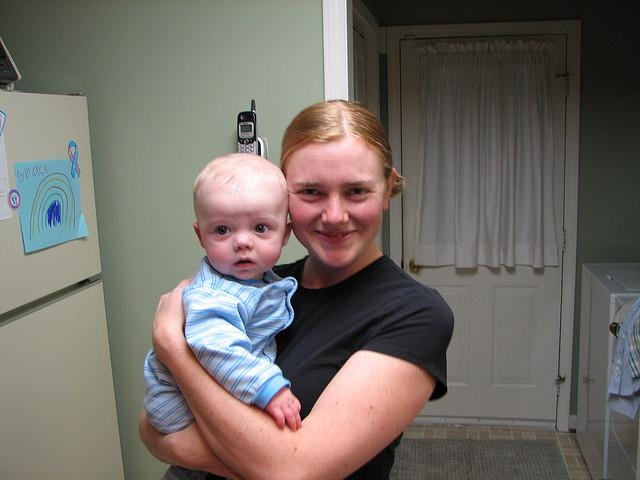Why is she smiling? Please explain your reasoning. is proud. She looks to be happy with the baby. 